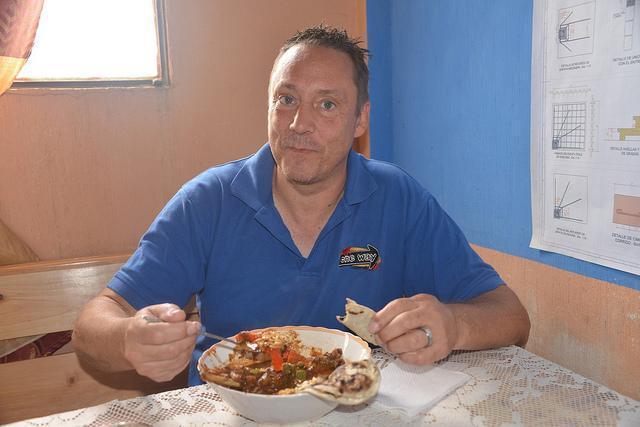How many apples are there?
Give a very brief answer. 0. 